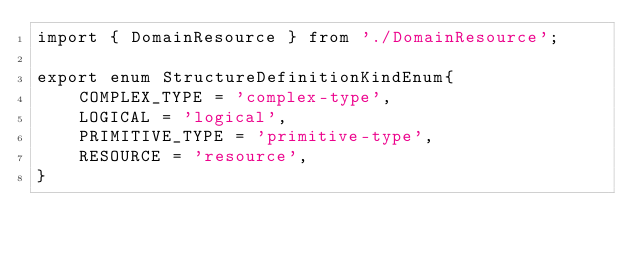<code> <loc_0><loc_0><loc_500><loc_500><_TypeScript_>import { DomainResource } from './DomainResource';

export enum StructureDefinitionKindEnum{
    COMPLEX_TYPE = 'complex-type',
    LOGICAL = 'logical',
    PRIMITIVE_TYPE = 'primitive-type',
    RESOURCE = 'resource',
}
</code> 